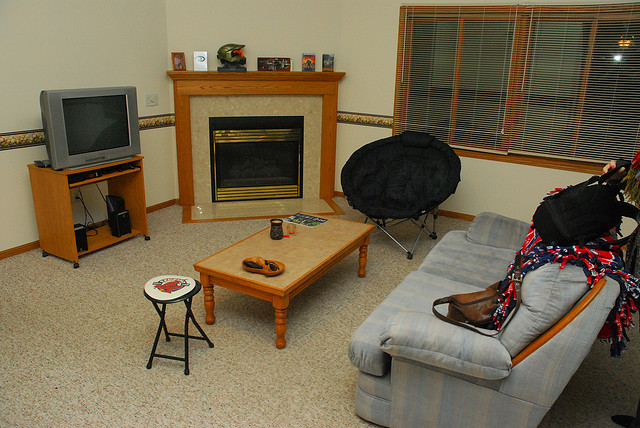<image>Where are tiles? I am not sure, tiles can be found around the fireplace, on the wall or floor. Where are tiles? The tiles are either around the fireplace or on the floor. 